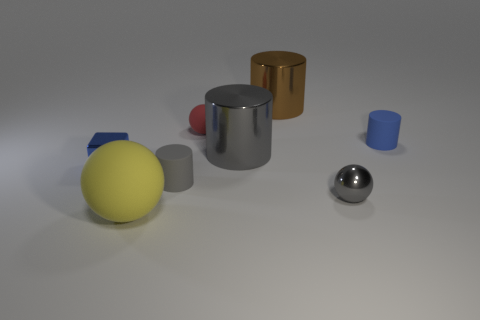Add 2 gray metal spheres. How many objects exist? 10 Subtract all brown cylinders. How many cylinders are left? 3 Subtract all brown cubes. How many gray cylinders are left? 2 Subtract 2 balls. How many balls are left? 1 Subtract all brown cylinders. How many cylinders are left? 3 Subtract all balls. How many objects are left? 5 Add 4 big brown things. How many big brown things exist? 5 Subtract 1 brown cylinders. How many objects are left? 7 Subtract all brown cubes. Subtract all purple cylinders. How many cubes are left? 1 Subtract all gray metallic spheres. Subtract all big cylinders. How many objects are left? 5 